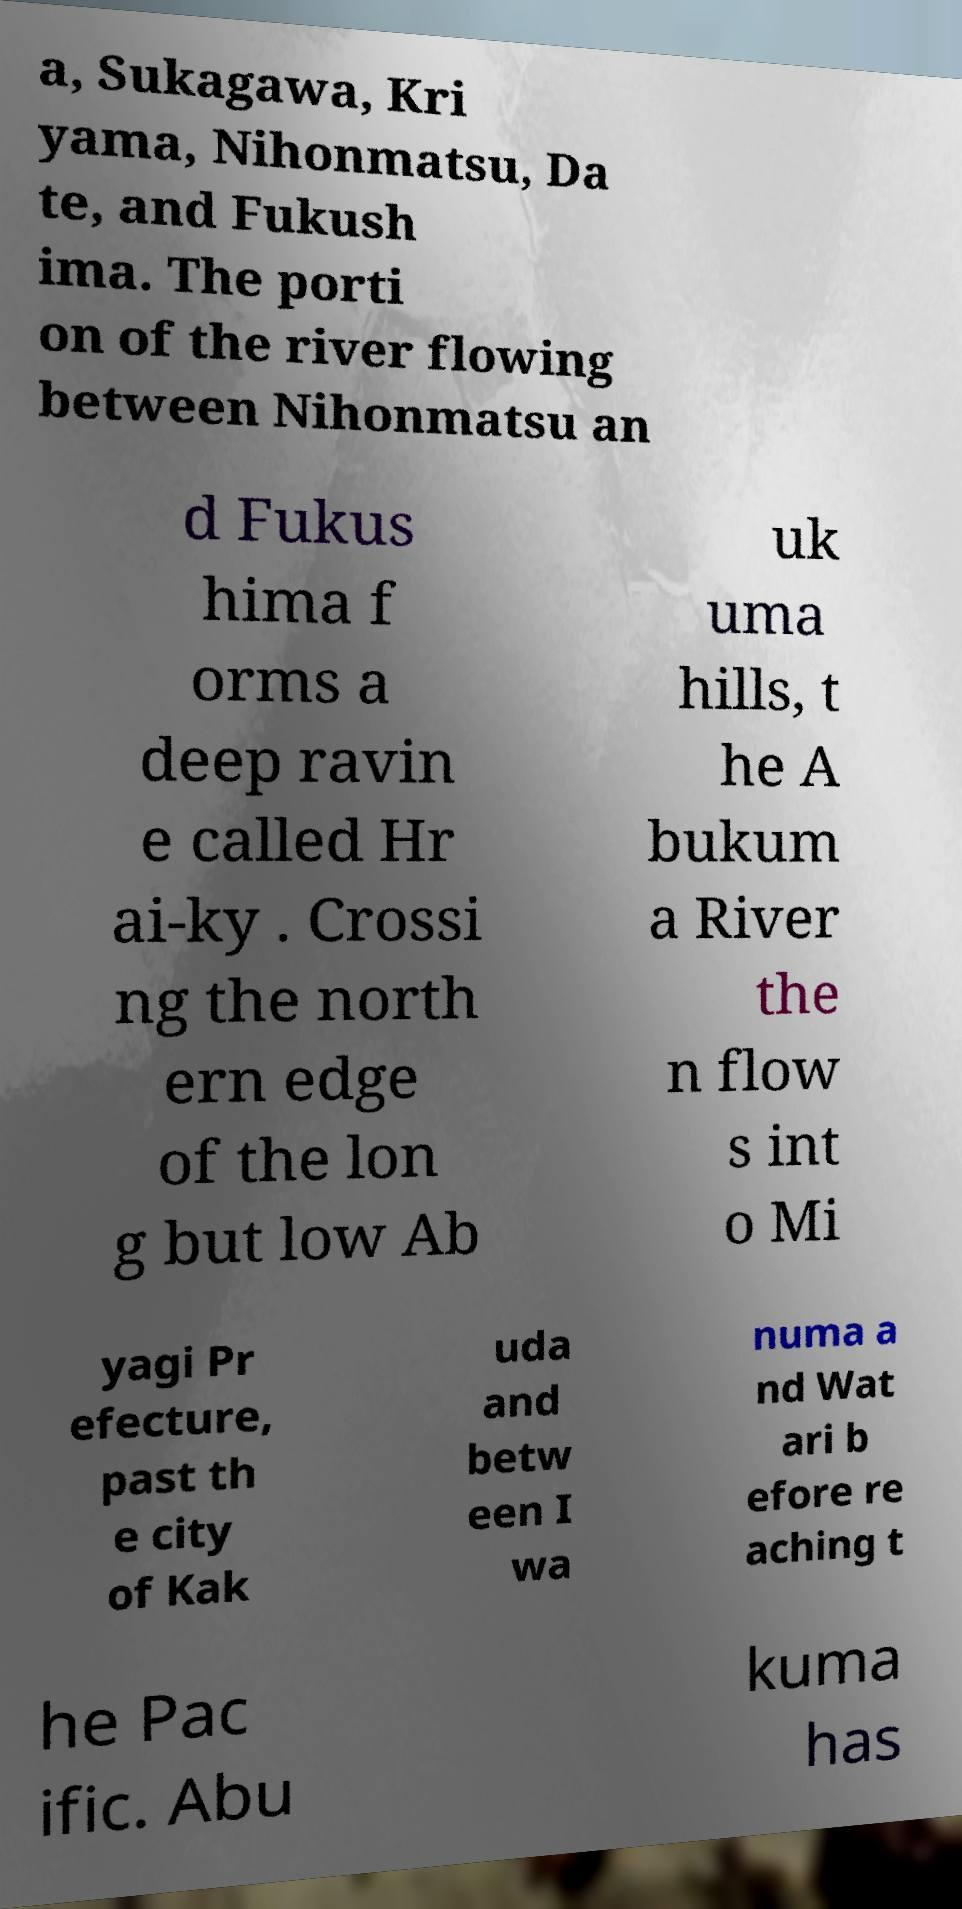Please read and relay the text visible in this image. What does it say? a, Sukagawa, Kri yama, Nihonmatsu, Da te, and Fukush ima. The porti on of the river flowing between Nihonmatsu an d Fukus hima f orms a deep ravin e called Hr ai-ky . Crossi ng the north ern edge of the lon g but low Ab uk uma hills, t he A bukum a River the n flow s int o Mi yagi Pr efecture, past th e city of Kak uda and betw een I wa numa a nd Wat ari b efore re aching t he Pac ific. Abu kuma has 